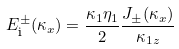<formula> <loc_0><loc_0><loc_500><loc_500>E _ { \text  i}^{\pm}(\kappa_{x}) = \frac{\kappa_{1} \eta _ { 1 } } { 2 } \frac { J _ { \pm } ( \kappa _ { x } ) } { \kappa _ { 1 z } }</formula> 